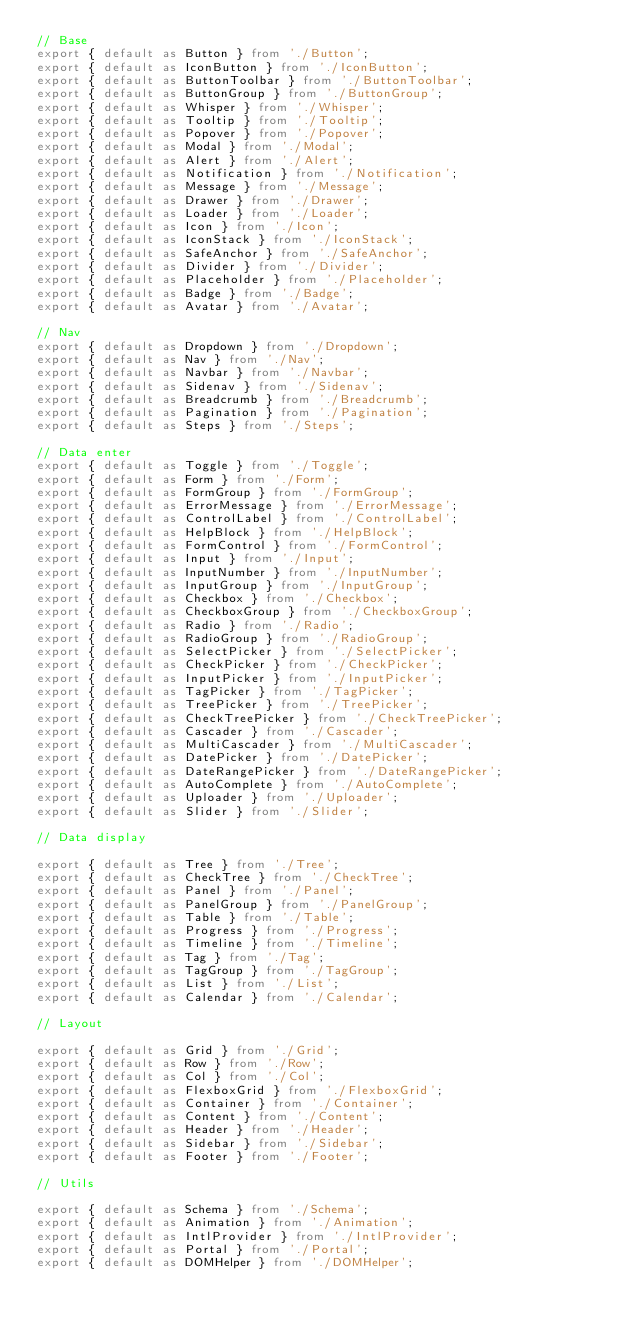<code> <loc_0><loc_0><loc_500><loc_500><_TypeScript_>// Base
export { default as Button } from './Button';
export { default as IconButton } from './IconButton';
export { default as ButtonToolbar } from './ButtonToolbar';
export { default as ButtonGroup } from './ButtonGroup';
export { default as Whisper } from './Whisper';
export { default as Tooltip } from './Tooltip';
export { default as Popover } from './Popover';
export { default as Modal } from './Modal';
export { default as Alert } from './Alert';
export { default as Notification } from './Notification';
export { default as Message } from './Message';
export { default as Drawer } from './Drawer';
export { default as Loader } from './Loader';
export { default as Icon } from './Icon';
export { default as IconStack } from './IconStack';
export { default as SafeAnchor } from './SafeAnchor';
export { default as Divider } from './Divider';
export { default as Placeholder } from './Placeholder';
export { default as Badge } from './Badge';
export { default as Avatar } from './Avatar';

// Nav
export { default as Dropdown } from './Dropdown';
export { default as Nav } from './Nav';
export { default as Navbar } from './Navbar';
export { default as Sidenav } from './Sidenav';
export { default as Breadcrumb } from './Breadcrumb';
export { default as Pagination } from './Pagination';
export { default as Steps } from './Steps';

// Data enter
export { default as Toggle } from './Toggle';
export { default as Form } from './Form';
export { default as FormGroup } from './FormGroup';
export { default as ErrorMessage } from './ErrorMessage';
export { default as ControlLabel } from './ControlLabel';
export { default as HelpBlock } from './HelpBlock';
export { default as FormControl } from './FormControl';
export { default as Input } from './Input';
export { default as InputNumber } from './InputNumber';
export { default as InputGroup } from './InputGroup';
export { default as Checkbox } from './Checkbox';
export { default as CheckboxGroup } from './CheckboxGroup';
export { default as Radio } from './Radio';
export { default as RadioGroup } from './RadioGroup';
export { default as SelectPicker } from './SelectPicker';
export { default as CheckPicker } from './CheckPicker';
export { default as InputPicker } from './InputPicker';
export { default as TagPicker } from './TagPicker';
export { default as TreePicker } from './TreePicker';
export { default as CheckTreePicker } from './CheckTreePicker';
export { default as Cascader } from './Cascader';
export { default as MultiCascader } from './MultiCascader';
export { default as DatePicker } from './DatePicker';
export { default as DateRangePicker } from './DateRangePicker';
export { default as AutoComplete } from './AutoComplete';
export { default as Uploader } from './Uploader';
export { default as Slider } from './Slider';

// Data display

export { default as Tree } from './Tree';
export { default as CheckTree } from './CheckTree';
export { default as Panel } from './Panel';
export { default as PanelGroup } from './PanelGroup';
export { default as Table } from './Table';
export { default as Progress } from './Progress';
export { default as Timeline } from './Timeline';
export { default as Tag } from './Tag';
export { default as TagGroup } from './TagGroup';
export { default as List } from './List';
export { default as Calendar } from './Calendar';

// Layout

export { default as Grid } from './Grid';
export { default as Row } from './Row';
export { default as Col } from './Col';
export { default as FlexboxGrid } from './FlexboxGrid';
export { default as Container } from './Container';
export { default as Content } from './Content';
export { default as Header } from './Header';
export { default as Sidebar } from './Sidebar';
export { default as Footer } from './Footer';

// Utils

export { default as Schema } from './Schema';
export { default as Animation } from './Animation';
export { default as IntlProvider } from './IntlProvider';
export { default as Portal } from './Portal';
export { default as DOMHelper } from './DOMHelper';
</code> 